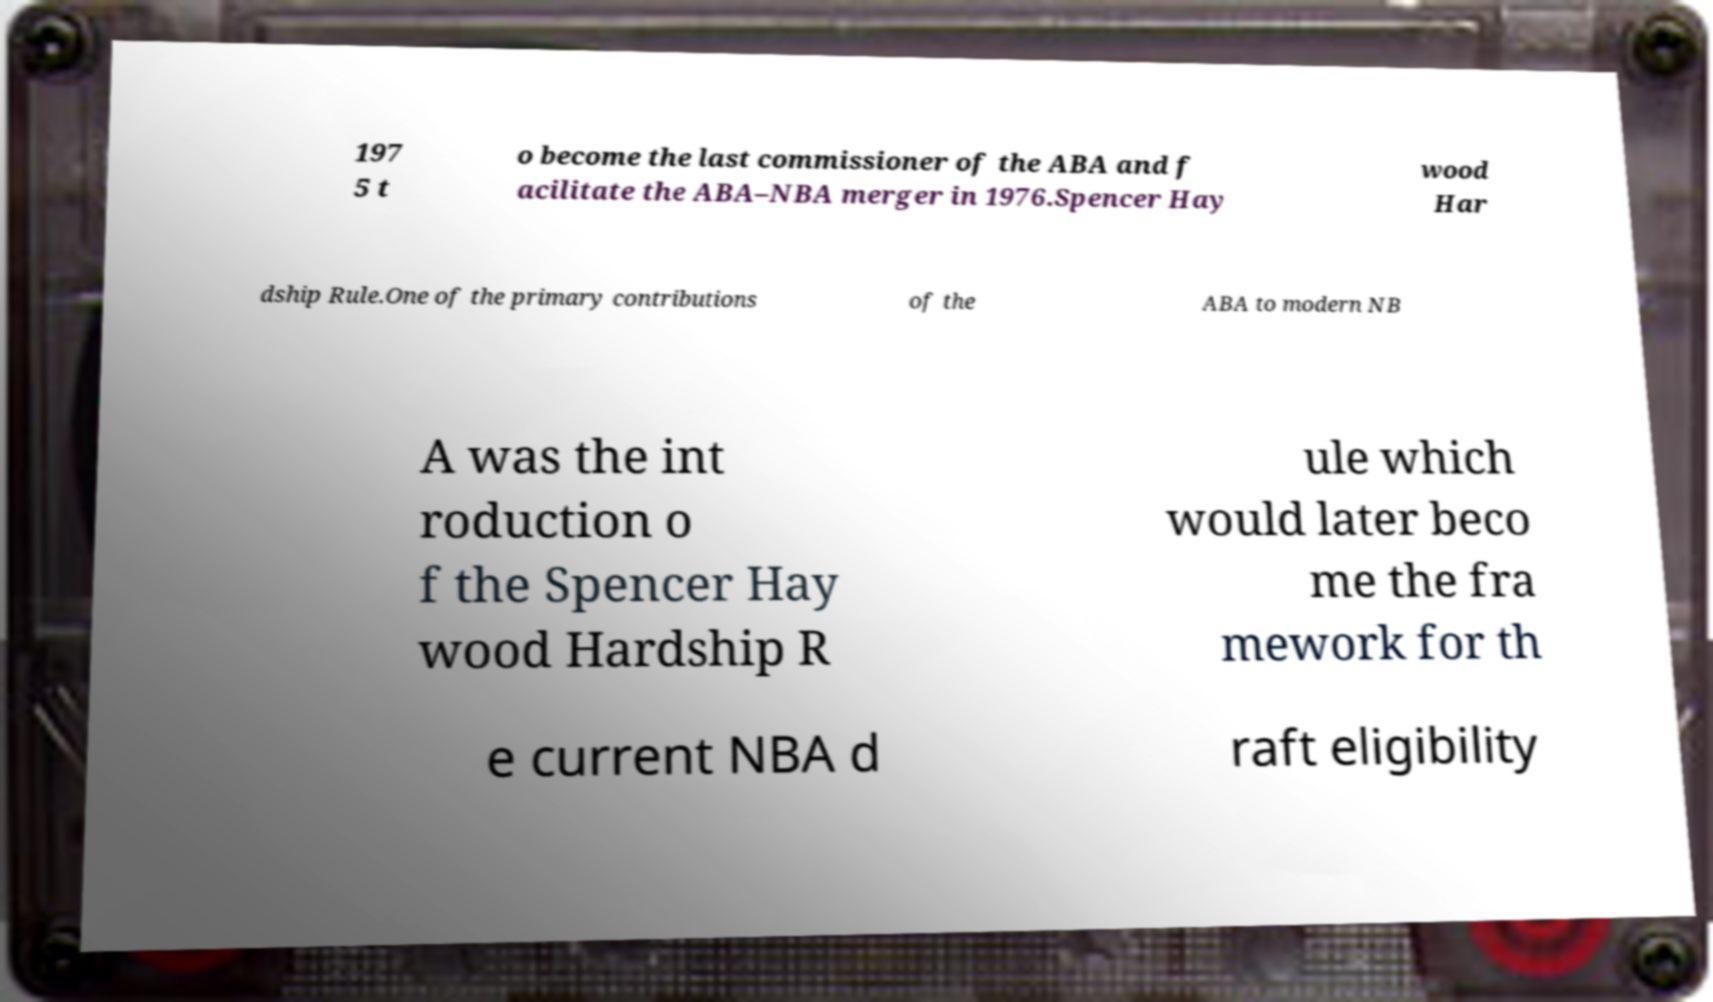What messages or text are displayed in this image? I need them in a readable, typed format. 197 5 t o become the last commissioner of the ABA and f acilitate the ABA–NBA merger in 1976.Spencer Hay wood Har dship Rule.One of the primary contributions of the ABA to modern NB A was the int roduction o f the Spencer Hay wood Hardship R ule which would later beco me the fra mework for th e current NBA d raft eligibility 